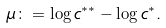Convert formula to latex. <formula><loc_0><loc_0><loc_500><loc_500>\mu \colon = \log c ^ { * * } - \log c ^ { * } .</formula> 